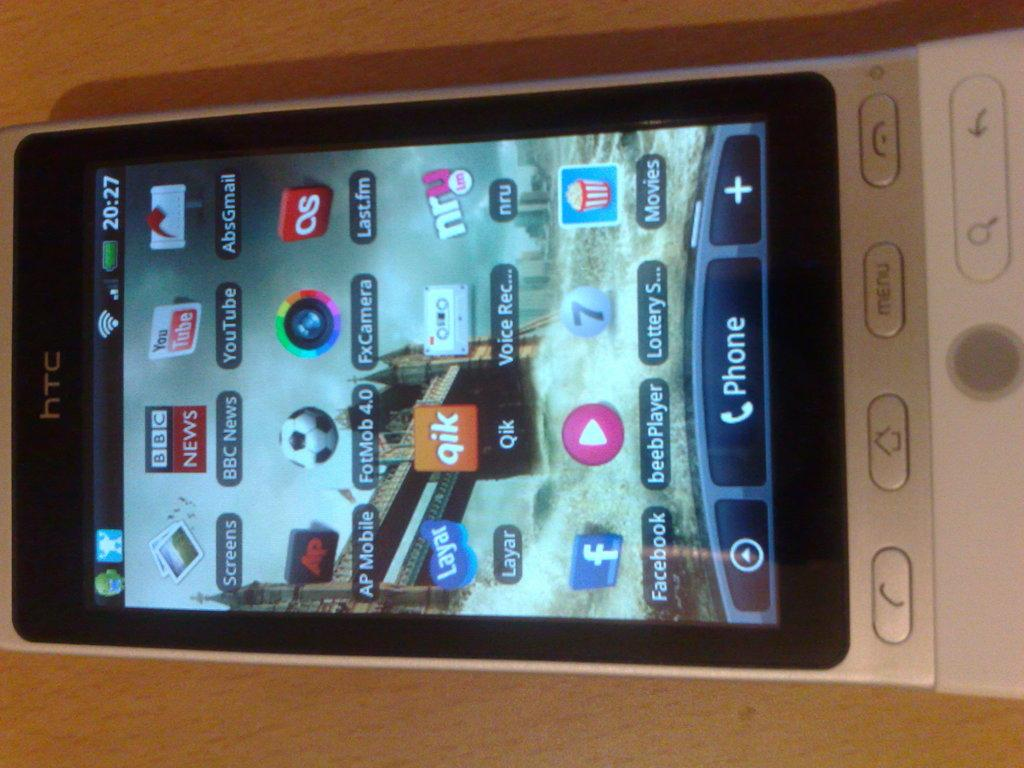<image>
Create a compact narrative representing the image presented. A HTC cell phone with a BBC News icon. 